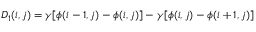Convert formula to latex. <formula><loc_0><loc_0><loc_500><loc_500>\begin{array} { r } { D _ { 1 } ( i , j ) = \gamma [ \phi ( i - 1 , j ) - \phi ( i , j ) ] - \gamma [ \phi ( i , j ) - \phi ( i + 1 , j ) ] } \end{array}</formula> 